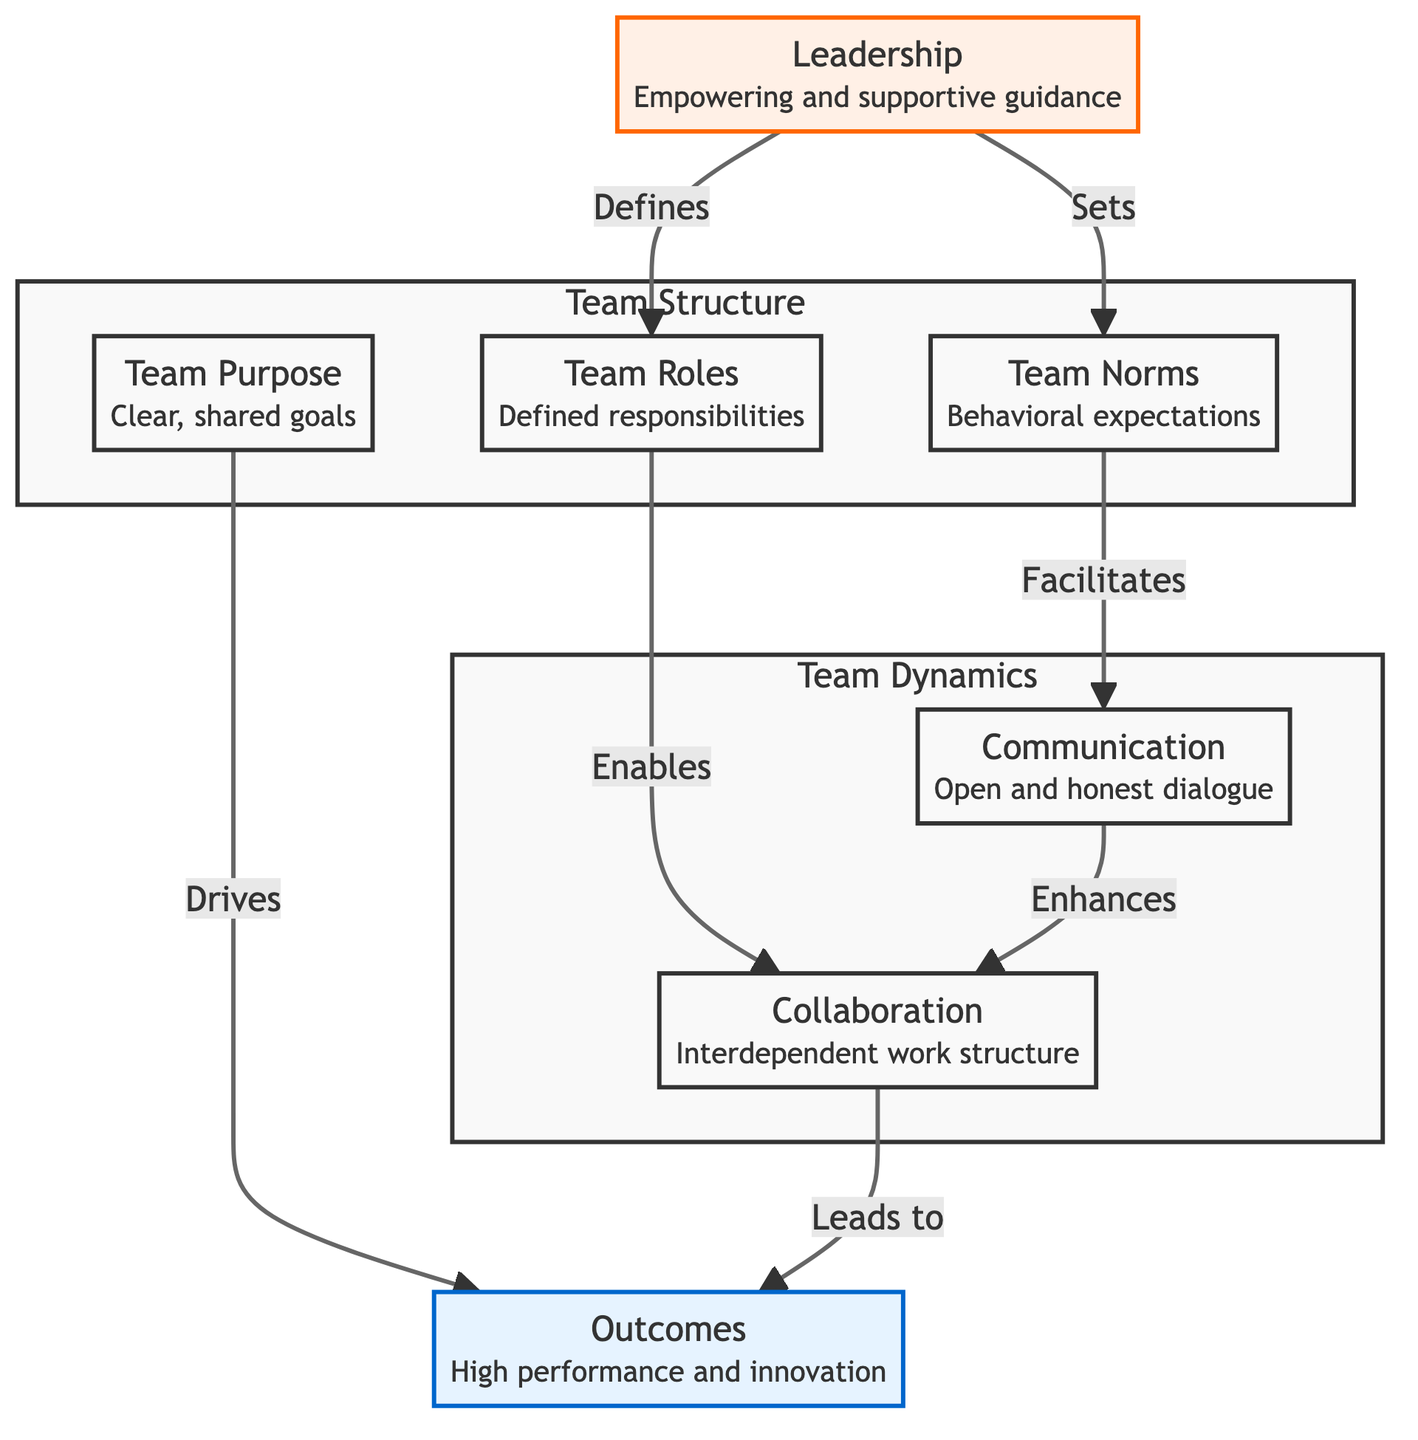What are the three main components of Team Structure? The diagram labels three nodes under the subgraph labeled "Team Structure": Team Purpose, Team Roles, and Team Norms.
Answer: Team Purpose, Team Roles, Team Norms How many outcomes are listed in the diagram? The diagram includes one node under the outcomes category, which is labeled "Outcomes". Therefore, there is one outcome listed in the diagram.
Answer: One What role does Leadership play in defining Team Norms? The diagram shows an arrow from Leadership to Team Norms, indicating that Leadership sets Team Norms. This means Leadership has a direct role in defining the behavioral expectations for the team.
Answer: Sets How do Communication and Collaboration relate to each other? The diagram illustrates that Communication enhances Collaboration, showing a directional relationship between the two nodes. This highlights that effective communication is essential for improved collaboration among team members.
Answer: Enhances What is the ultimate result of the interactions within the diagram? The diagram indicates that all paths lead to the Outcomes node, which is labeled as "High performance and innovation". This suggests that the culmination of all team functions results in these two outcomes.
Answer: High performance and innovation Which two components are directly linked to Leadership? The diagram shows arrows leading from Leadership to both Team Roles and Team Norms. This means Leadership is directly linked to defining both these components within the team structure.
Answer: Team Roles, Team Norms What is indicated by the relationship between Team Norms and Communication? The diagram indicates that Team Norms facilitates Communication, suggesting that the established behavioral expectations (norms) directly support and enhance open and honest dialogue among team members.
Answer: Facilitates How many total nodes are present in the diagram? By counting the distinct nodes in the diagram, we find there are seven nodes: Team Purpose, Team Roles, Team Norms, Communication, Collaboration, Outcomes, and Leadership.
Answer: Seven 